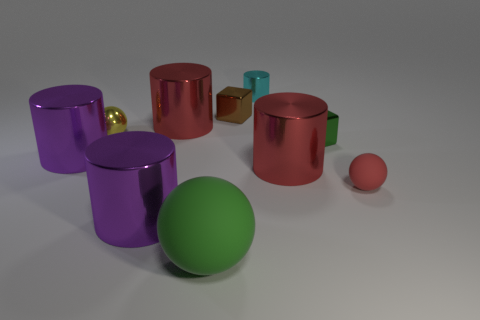There is a cyan thing that is on the right side of the green matte sphere; what material is it?
Offer a very short reply. Metal. Are there the same number of spheres on the right side of the small rubber sphere and yellow cylinders?
Your answer should be very brief. Yes. Does the yellow sphere have the same size as the green matte sphere?
Your answer should be very brief. No. Are there any big green matte things on the right side of the big red metallic thing that is behind the tiny metallic block in front of the brown thing?
Provide a short and direct response. Yes. There is another thing that is the same shape as the tiny green thing; what is it made of?
Give a very brief answer. Metal. What number of large red cylinders are to the left of the red shiny cylinder that is in front of the green shiny thing?
Ensure brevity in your answer.  1. There is a purple metal thing that is behind the purple metal object in front of the purple thing that is behind the tiny red rubber ball; how big is it?
Your answer should be very brief. Large. There is a shiny cube behind the large metal thing behind the tiny yellow ball; what is its color?
Ensure brevity in your answer.  Brown. How many other objects are there of the same material as the large green thing?
Give a very brief answer. 1. How many other things are the same color as the small matte sphere?
Offer a terse response. 2. 